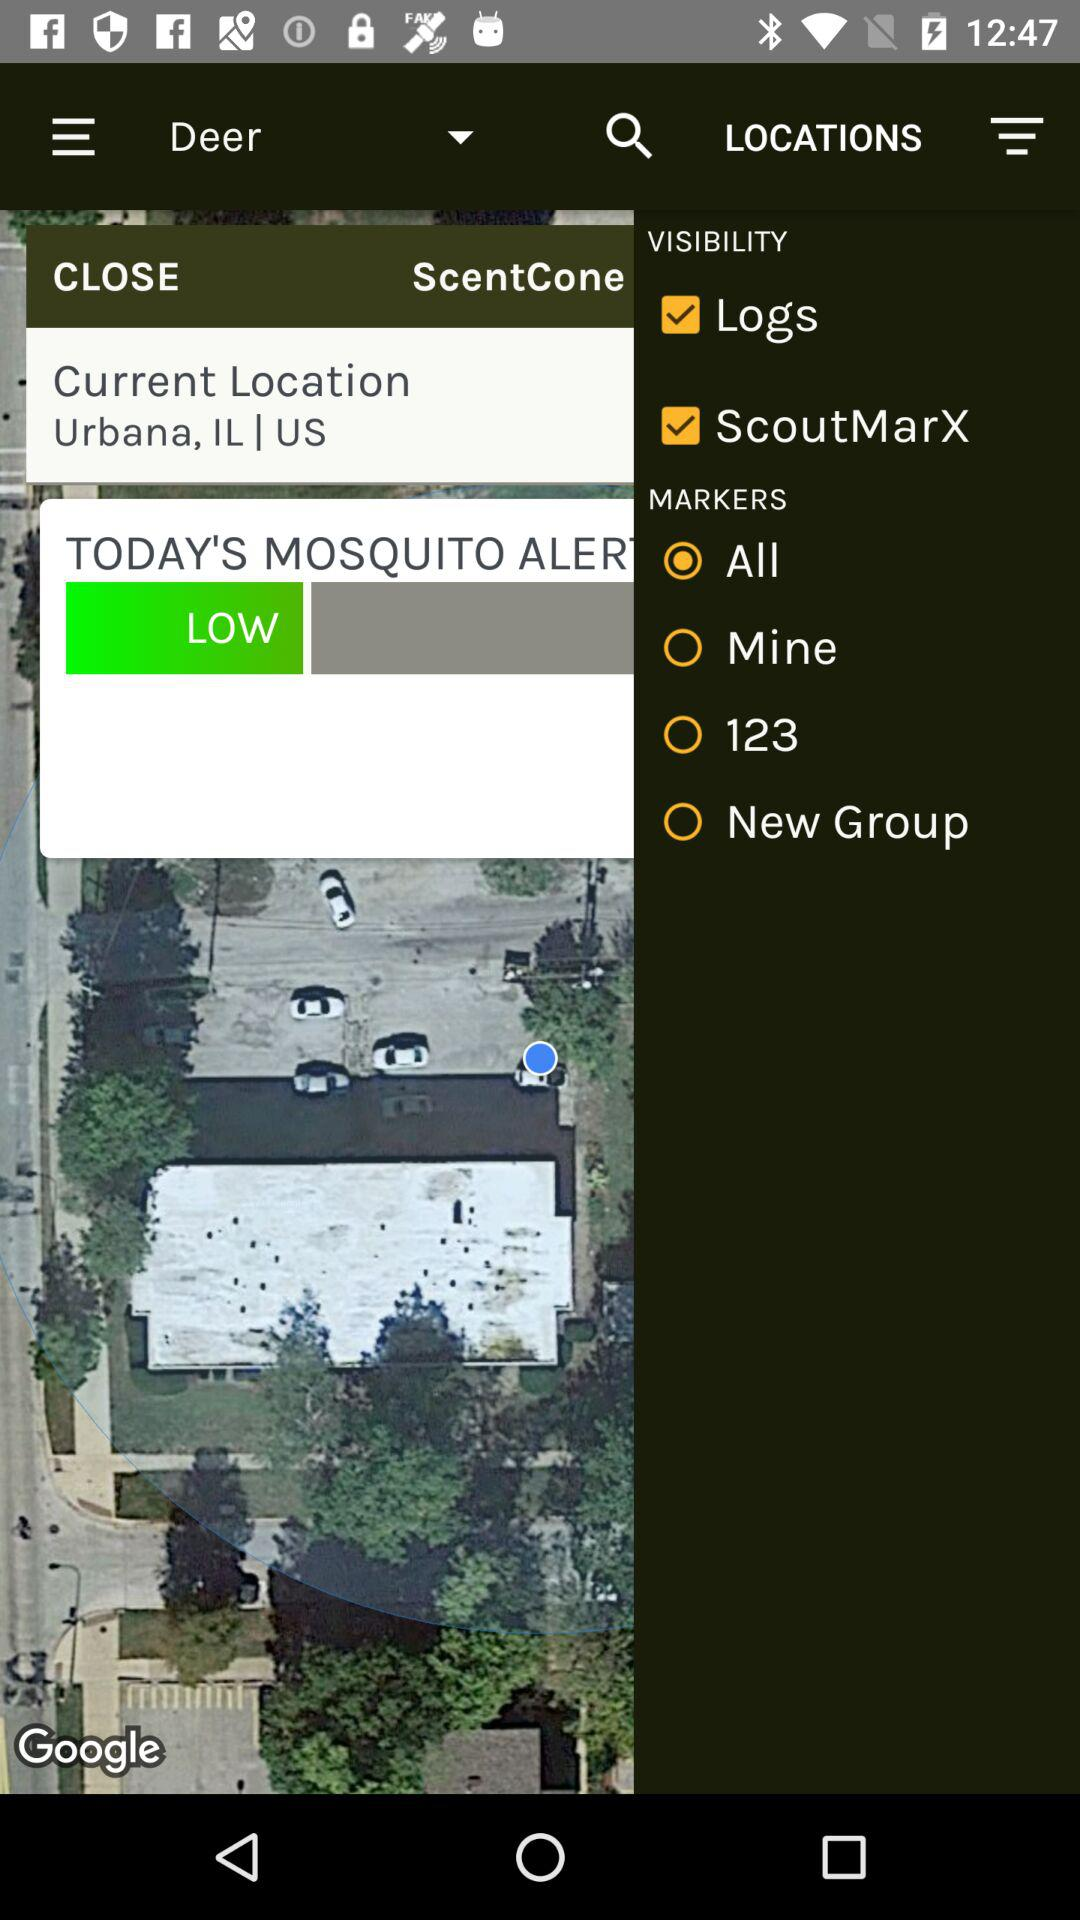Which different visibility options are there? The different visibility options are "Logs" and "ScoutMarX". 